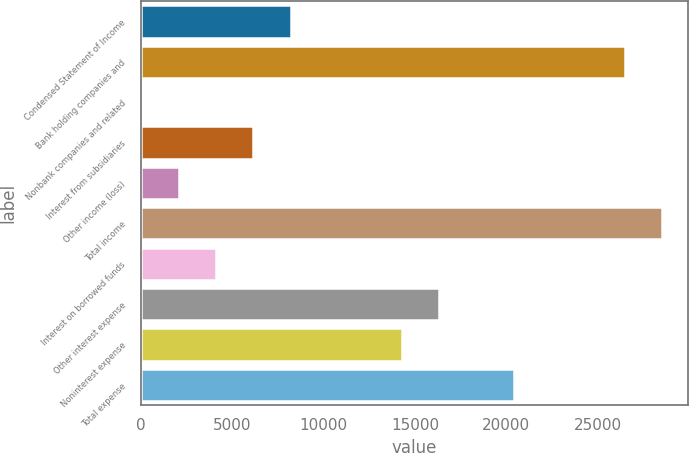<chart> <loc_0><loc_0><loc_500><loc_500><bar_chart><fcel>Condensed Statement of Income<fcel>Bank holding companies and<fcel>Nonbank companies and related<fcel>Interest from subsidiaries<fcel>Other income (loss)<fcel>Total income<fcel>Interest on borrowed funds<fcel>Other interest expense<fcel>Noninterest expense<fcel>Total expense<nl><fcel>8193.4<fcel>26509.3<fcel>53<fcel>6158.3<fcel>2088.1<fcel>28544.4<fcel>4123.2<fcel>16333.8<fcel>14298.7<fcel>20404<nl></chart> 